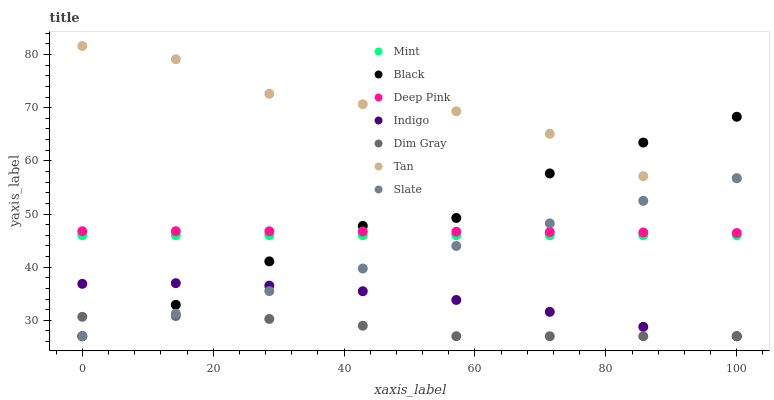Does Dim Gray have the minimum area under the curve?
Answer yes or no. Yes. Does Tan have the maximum area under the curve?
Answer yes or no. Yes. Does Indigo have the minimum area under the curve?
Answer yes or no. No. Does Indigo have the maximum area under the curve?
Answer yes or no. No. Is Slate the smoothest?
Answer yes or no. Yes. Is Tan the roughest?
Answer yes or no. Yes. Is Indigo the smoothest?
Answer yes or no. No. Is Indigo the roughest?
Answer yes or no. No. Does Dim Gray have the lowest value?
Answer yes or no. Yes. Does Deep Pink have the lowest value?
Answer yes or no. No. Does Tan have the highest value?
Answer yes or no. Yes. Does Indigo have the highest value?
Answer yes or no. No. Is Mint less than Tan?
Answer yes or no. Yes. Is Deep Pink greater than Mint?
Answer yes or no. Yes. Does Slate intersect Dim Gray?
Answer yes or no. Yes. Is Slate less than Dim Gray?
Answer yes or no. No. Is Slate greater than Dim Gray?
Answer yes or no. No. Does Mint intersect Tan?
Answer yes or no. No. 